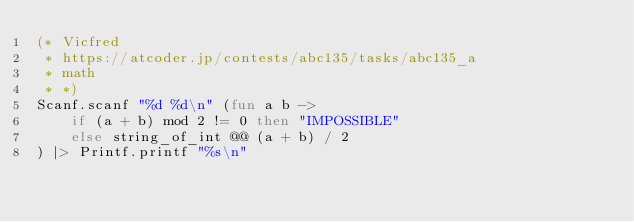<code> <loc_0><loc_0><loc_500><loc_500><_OCaml_>(* Vicfred
 * https://atcoder.jp/contests/abc135/tasks/abc135_a
 * math
 * *)
Scanf.scanf "%d %d\n" (fun a b ->
    if (a + b) mod 2 != 0 then "IMPOSSIBLE"
    else string_of_int @@ (a + b) / 2
) |> Printf.printf "%s\n"

</code> 